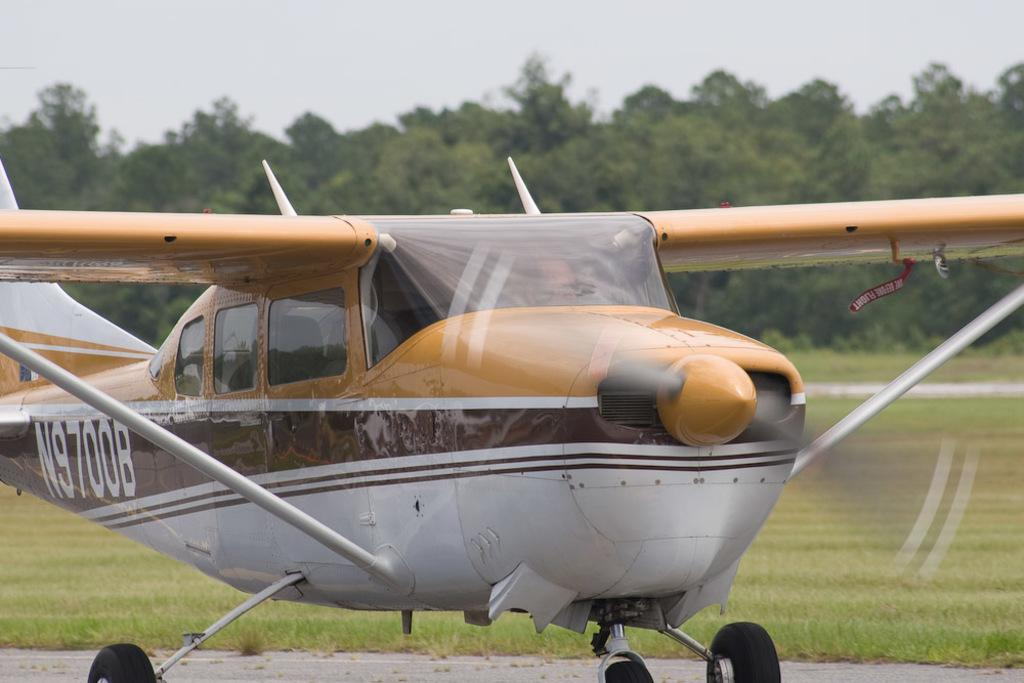<image>
Relay a brief, clear account of the picture shown. A plane with N9700B painted on its tail end. 